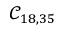<formula> <loc_0><loc_0><loc_500><loc_500>\mathcal { C } _ { 1 8 , 3 5 }</formula> 